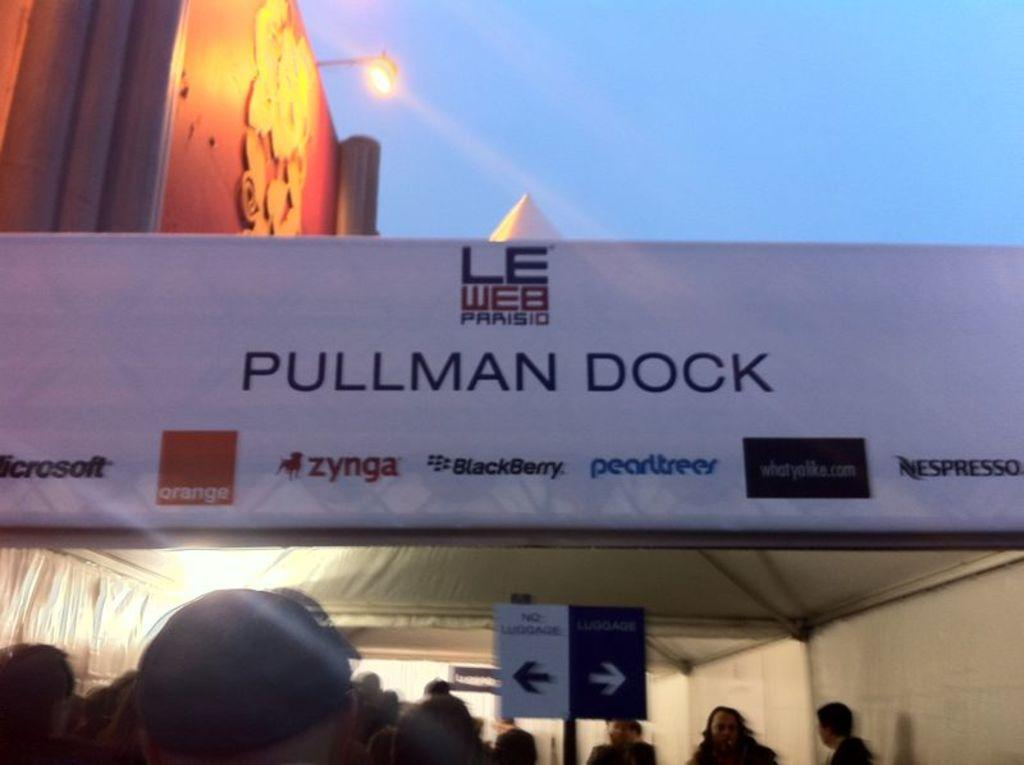Provide a one-sentence caption for the provided image. Many people are under a tent that states pullman dock for an event. 